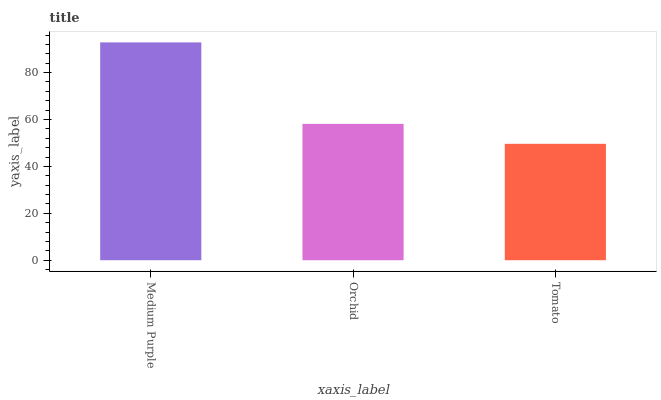Is Tomato the minimum?
Answer yes or no. Yes. Is Medium Purple the maximum?
Answer yes or no. Yes. Is Orchid the minimum?
Answer yes or no. No. Is Orchid the maximum?
Answer yes or no. No. Is Medium Purple greater than Orchid?
Answer yes or no. Yes. Is Orchid less than Medium Purple?
Answer yes or no. Yes. Is Orchid greater than Medium Purple?
Answer yes or no. No. Is Medium Purple less than Orchid?
Answer yes or no. No. Is Orchid the high median?
Answer yes or no. Yes. Is Orchid the low median?
Answer yes or no. Yes. Is Tomato the high median?
Answer yes or no. No. Is Tomato the low median?
Answer yes or no. No. 